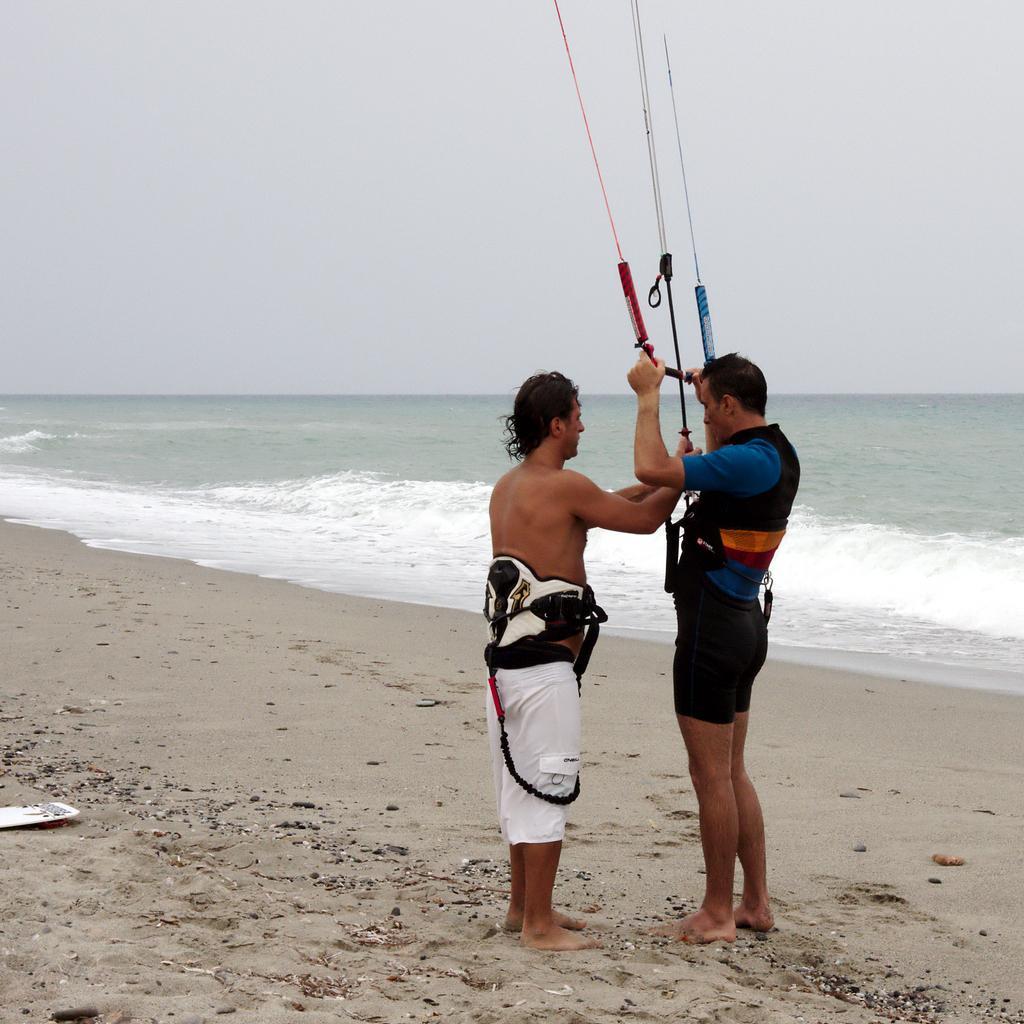Could you give a brief overview of what you see in this image? In this image there are two men standing on a sand surface, in the background there is the sea and the sky. 